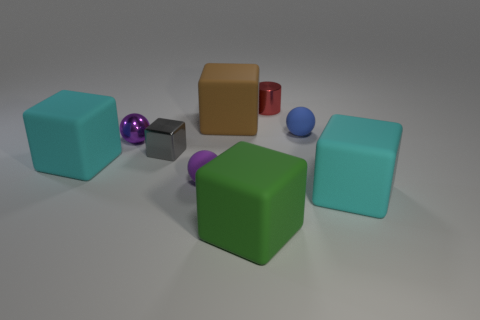What number of things are either large cyan things or small blue objects?
Ensure brevity in your answer.  3. What is the material of the tiny ball that is in front of the big cyan matte thing to the left of the tiny blue matte thing?
Provide a short and direct response. Rubber. Are there any large green spheres that have the same material as the big green block?
Your answer should be compact. No. What shape is the small matte thing behind the cyan rubber object that is behind the large cyan rubber thing that is to the right of the shiny ball?
Your answer should be very brief. Sphere. What is the material of the gray object?
Your response must be concise. Metal. There is a block that is made of the same material as the small cylinder; what is its color?
Keep it short and to the point. Gray. Is there a gray cube that is in front of the big thing left of the brown block?
Give a very brief answer. No. How many other things are there of the same shape as the purple rubber thing?
Make the answer very short. 2. There is a big rubber object that is right of the red shiny cylinder; is its shape the same as the cyan rubber thing to the left of the shiny ball?
Ensure brevity in your answer.  Yes. There is a large matte cube that is behind the large cyan object that is on the left side of the red cylinder; how many large objects are on the right side of it?
Offer a terse response. 2. 